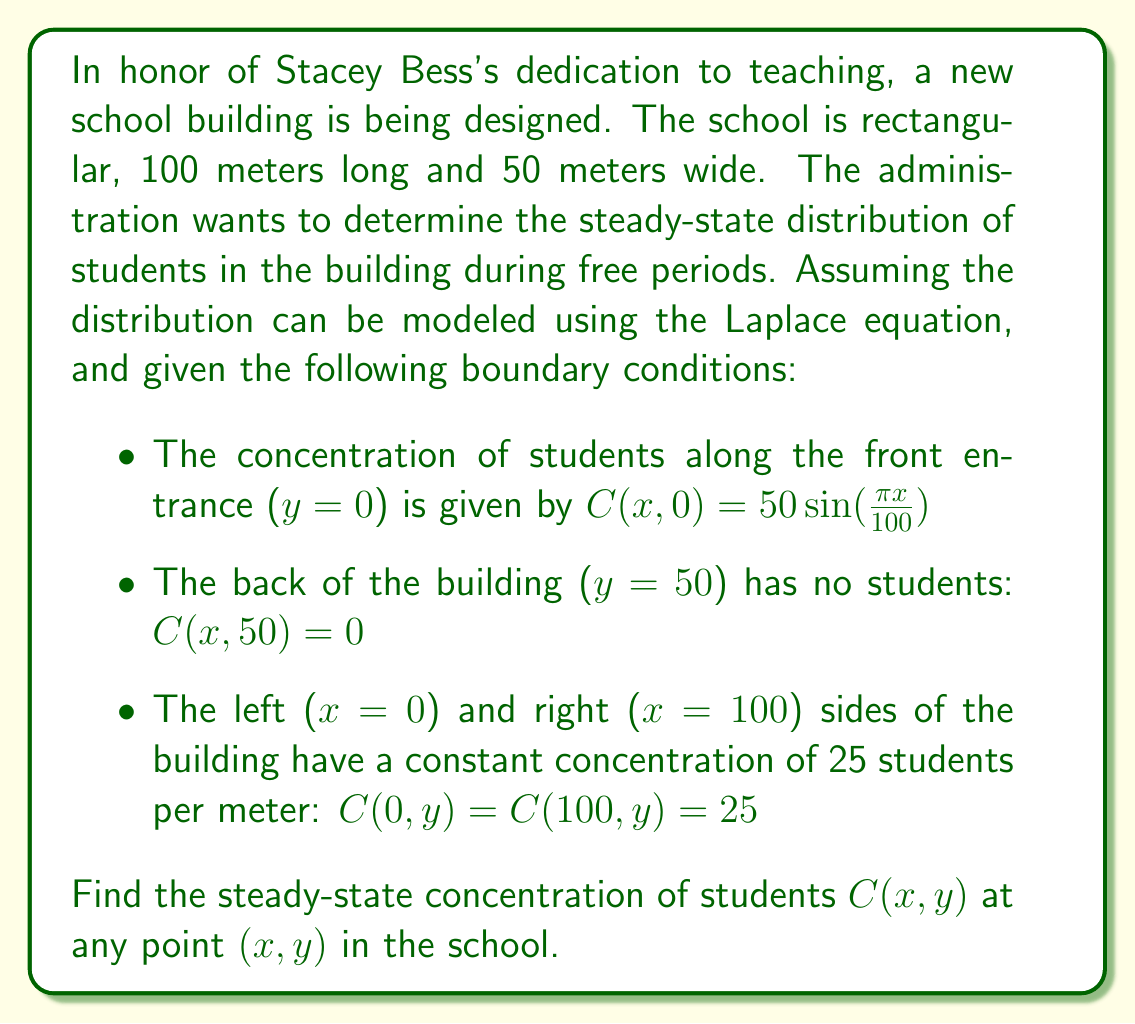Show me your answer to this math problem. To solve this problem, we need to use the method of separation of variables for the Laplace equation in two dimensions:

1) The Laplace equation in 2D is:

   $$\frac{\partial^2C}{\partial x^2} + \frac{\partial^2C}{\partial y^2} = 0$$

2) We assume a solution of the form $C(x,y) = X(x)Y(y)$

3) Substituting this into the Laplace equation and dividing by XY, we get:

   $$\frac{X''}{X} + \frac{Y''}{Y} = 0$$

4) This implies $\frac{X''}{X} = -\frac{Y''}{Y} = k^2$ (constant)

5) So we have two ordinary differential equations:
   
   $X'' + k^2X = 0$ and $Y'' - k^2Y = 0$

6) The general solutions are:
   
   $X(x) = A\cos(kx) + B\sin(kx)$
   $Y(y) = Ce^{ky} + De^{-ky}$

7) Applying the boundary conditions:

   For $y = 50$: $C(x,50) = 0$ implies $Ce^{50k} + De^{-50k} = 0$

   For $x = 0$ and $x = 100$: $C(0,y) = C(100,y) = 25$ implies $A = 25$ and $\cos(100k) = 1$

   The last condition gives us $k = \frac{n\pi}{100}$ where $n$ is an integer.

8) For $y = 0$: $C(x,0) = 50\sin(\frac{\pi x}{100})$

   This implies that only $n = 1$ is needed in our solution.

9) The final solution is of the form:

   $$C(x,y) = 25 + \left(50\sin(\frac{\pi x}{100}) - 25\right)\frac{\sinh(\frac{\pi(50-y)}{100})}{\sinh(\frac{50\pi}{100})}$$

This satisfies all boundary conditions and the Laplace equation.
Answer: The steady-state concentration of students at any point $(x,y)$ in the school is given by:

$$C(x,y) = 25 + \left(50\sin(\frac{\pi x}{100}) - 25\right)\frac{\sinh(\frac{\pi(50-y)}{100})}{\sinh(\frac{50\pi}{100})}$$

where $x$ is the distance from the left side of the building (0 ≤ x ≤ 100) and $y$ is the distance from the front entrance (0 ≤ y ≤ 50), both measured in meters. 